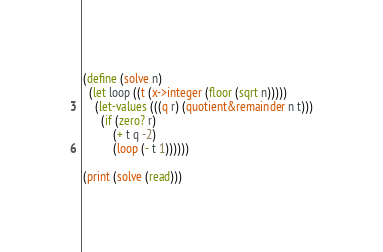Convert code to text. <code><loc_0><loc_0><loc_500><loc_500><_Scheme_>(define (solve n)
  (let loop ((t (x->integer (floor (sqrt n)))))
    (let-values (((q r) (quotient&remainder n t)))
      (if (zero? r)
          (+ t q -2)
          (loop (- t 1))))))

(print (solve (read)))
</code> 